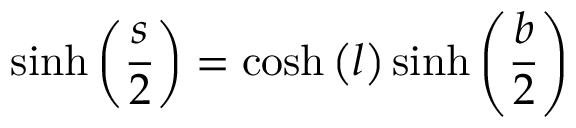<formula> <loc_0><loc_0><loc_500><loc_500>\sinh \left ( { \frac { s } { 2 } } \right ) = \cosh \left ( l \right ) \sinh \left ( { \frac { b } { 2 } } \right )</formula> 